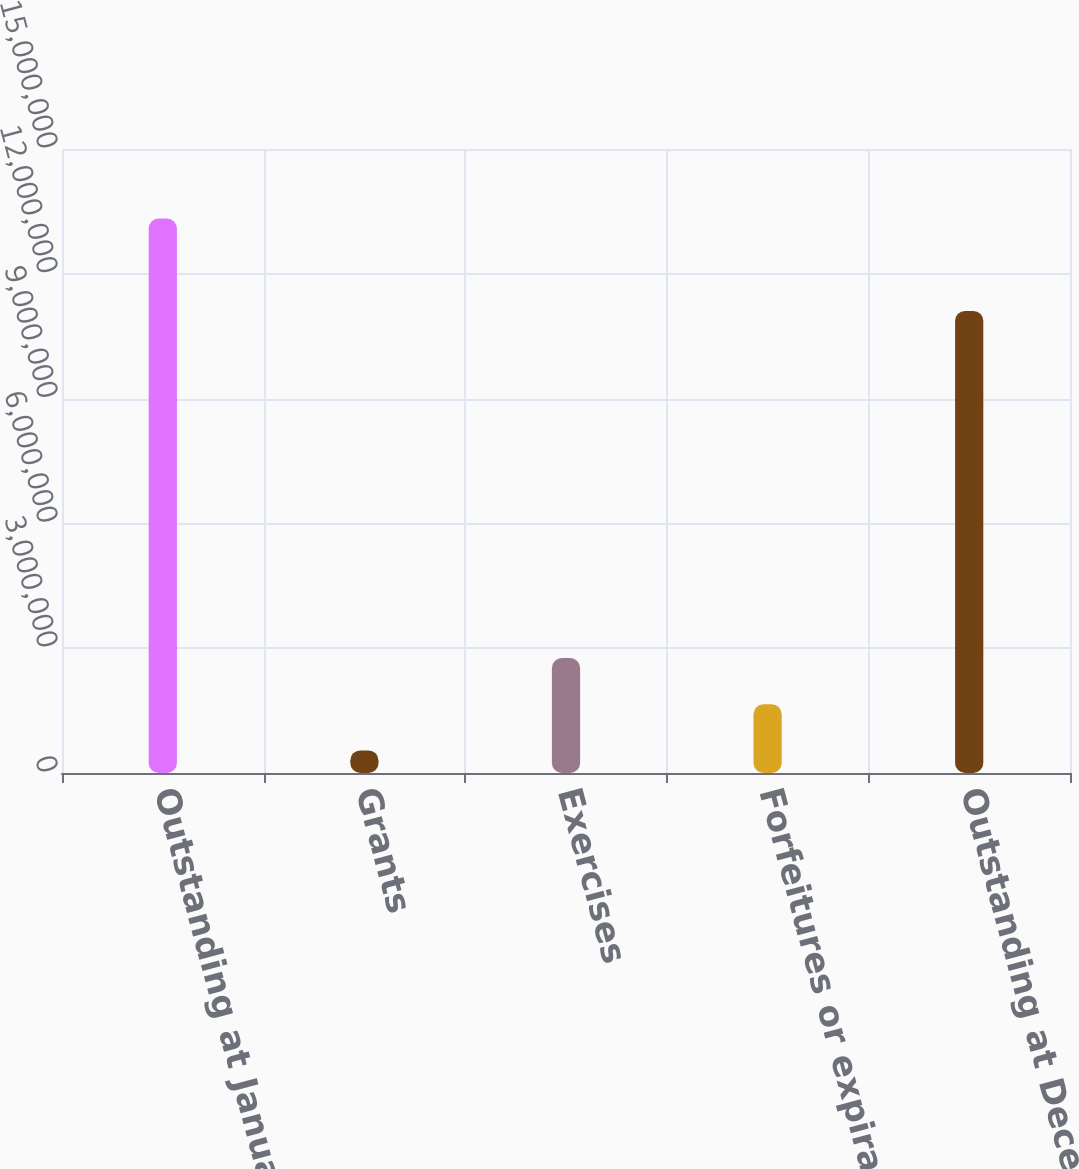Convert chart. <chart><loc_0><loc_0><loc_500><loc_500><bar_chart><fcel>Outstanding at January 1 2007<fcel>Grants<fcel>Exercises<fcel>Forfeitures or expirations<fcel>Outstanding at December 31<nl><fcel>1.33284e+07<fcel>542879<fcel>2.7631e+06<fcel>1.65299e+06<fcel>1.11082e+07<nl></chart> 